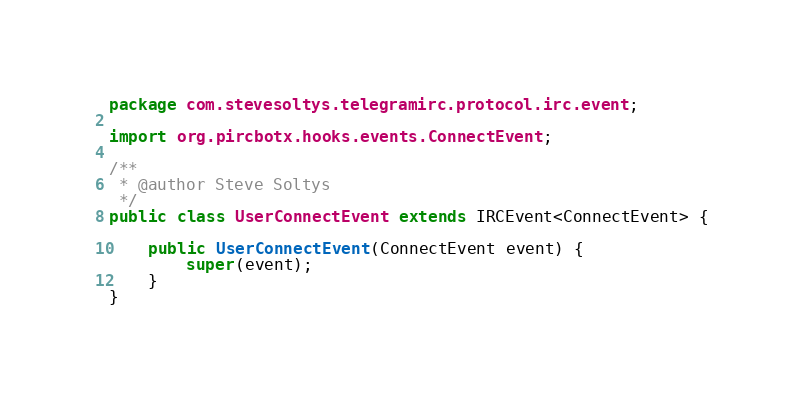<code> <loc_0><loc_0><loc_500><loc_500><_Java_>package com.stevesoltys.telegramirc.protocol.irc.event;

import org.pircbotx.hooks.events.ConnectEvent;

/**
 * @author Steve Soltys
 */
public class UserConnectEvent extends IRCEvent<ConnectEvent> {

    public UserConnectEvent(ConnectEvent event) {
        super(event);
    }
}
</code> 